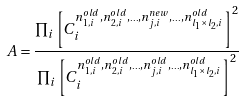Convert formula to latex. <formula><loc_0><loc_0><loc_500><loc_500>A = \frac { \prod _ { i } \left [ C _ { i } ^ { n _ { 1 , i } ^ { o l d } , n _ { 2 , i } ^ { o l d } , _ { \cdots } , n _ { j , i } ^ { n e w } , _ { \cdots } , n _ { l _ { 1 } \times l _ { 2 } , i } ^ { o l d } } \right ] ^ { 2 } } { \prod _ { i } \left [ C _ { i } ^ { n _ { 1 , i } ^ { o l d } , n _ { 2 , i } ^ { o l d } , _ { \cdots } , n _ { j , i } ^ { o l d } , _ { \cdots } , n _ { l _ { 1 } \times l _ { 2 } , i } ^ { o l d } } \right ] ^ { 2 } }</formula> 